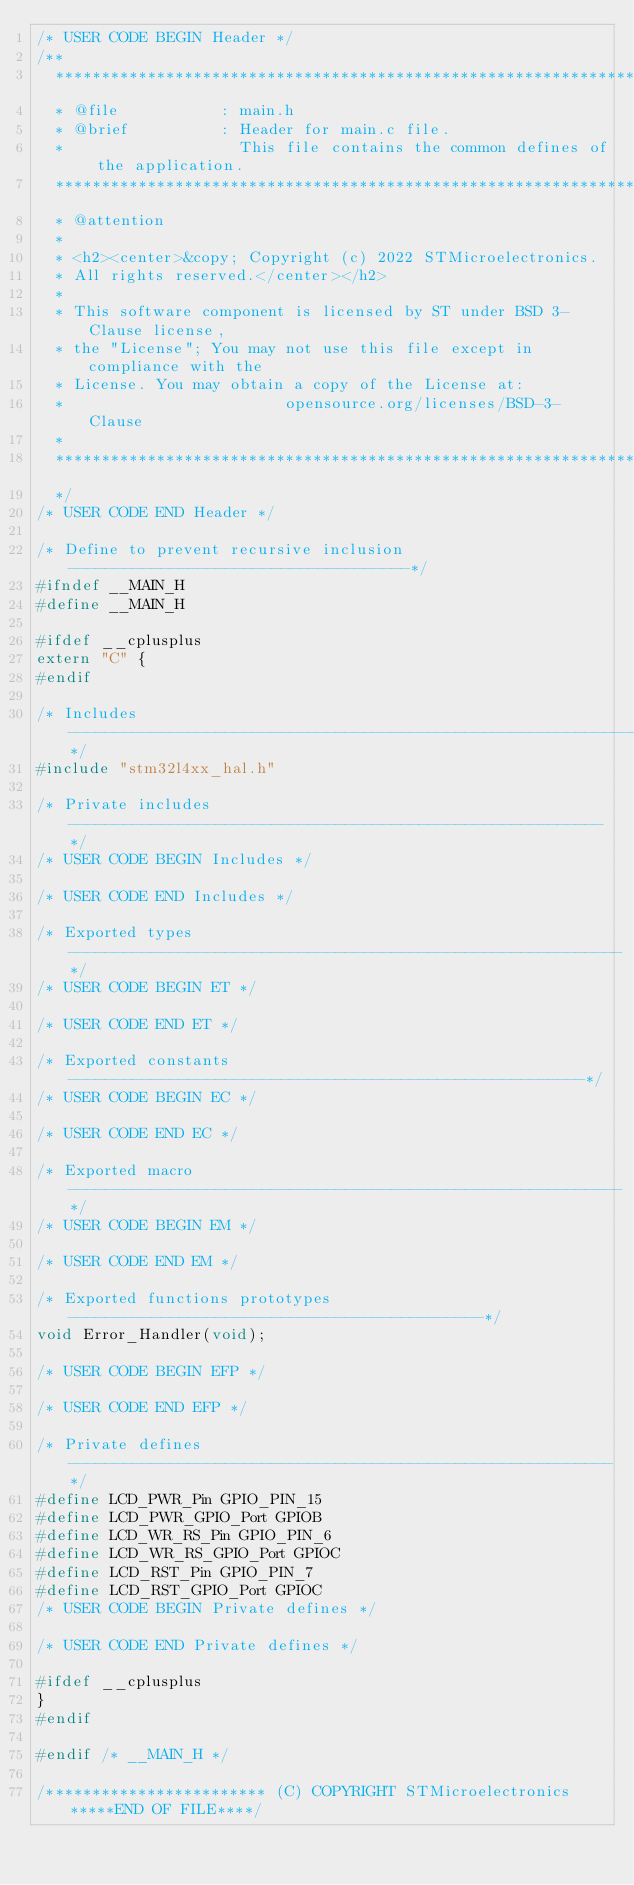Convert code to text. <code><loc_0><loc_0><loc_500><loc_500><_C_>/* USER CODE BEGIN Header */
/**
  ******************************************************************************
  * @file           : main.h
  * @brief          : Header for main.c file.
  *                   This file contains the common defines of the application.
  ******************************************************************************
  * @attention
  *
  * <h2><center>&copy; Copyright (c) 2022 STMicroelectronics.
  * All rights reserved.</center></h2>
  *
  * This software component is licensed by ST under BSD 3-Clause license,
  * the "License"; You may not use this file except in compliance with the
  * License. You may obtain a copy of the License at:
  *                        opensource.org/licenses/BSD-3-Clause
  *
  ******************************************************************************
  */
/* USER CODE END Header */

/* Define to prevent recursive inclusion -------------------------------------*/
#ifndef __MAIN_H
#define __MAIN_H

#ifdef __cplusplus
extern "C" {
#endif

/* Includes ------------------------------------------------------------------*/
#include "stm32l4xx_hal.h"

/* Private includes ----------------------------------------------------------*/
/* USER CODE BEGIN Includes */

/* USER CODE END Includes */

/* Exported types ------------------------------------------------------------*/
/* USER CODE BEGIN ET */

/* USER CODE END ET */

/* Exported constants --------------------------------------------------------*/
/* USER CODE BEGIN EC */

/* USER CODE END EC */

/* Exported macro ------------------------------------------------------------*/
/* USER CODE BEGIN EM */

/* USER CODE END EM */

/* Exported functions prototypes ---------------------------------------------*/
void Error_Handler(void);

/* USER CODE BEGIN EFP */

/* USER CODE END EFP */

/* Private defines -----------------------------------------------------------*/
#define LCD_PWR_Pin GPIO_PIN_15
#define LCD_PWR_GPIO_Port GPIOB
#define LCD_WR_RS_Pin GPIO_PIN_6
#define LCD_WR_RS_GPIO_Port GPIOC
#define LCD_RST_Pin GPIO_PIN_7
#define LCD_RST_GPIO_Port GPIOC
/* USER CODE BEGIN Private defines */

/* USER CODE END Private defines */

#ifdef __cplusplus
}
#endif

#endif /* __MAIN_H */

/************************ (C) COPYRIGHT STMicroelectronics *****END OF FILE****/
</code> 